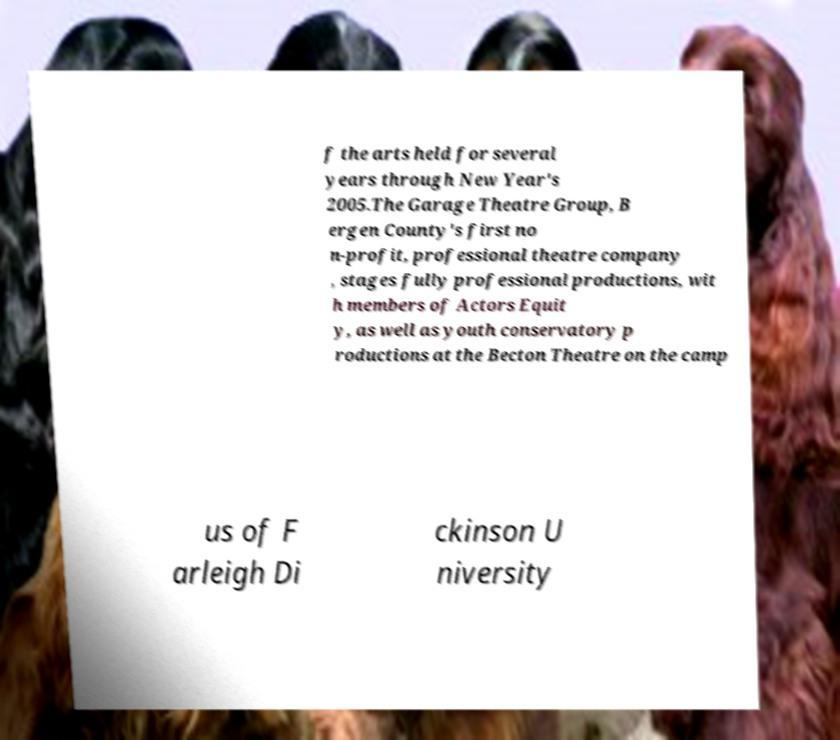Please identify and transcribe the text found in this image. f the arts held for several years through New Year's 2005.The Garage Theatre Group, B ergen County's first no n-profit, professional theatre company , stages fully professional productions, wit h members of Actors Equit y, as well as youth conservatory p roductions at the Becton Theatre on the camp us of F arleigh Di ckinson U niversity 